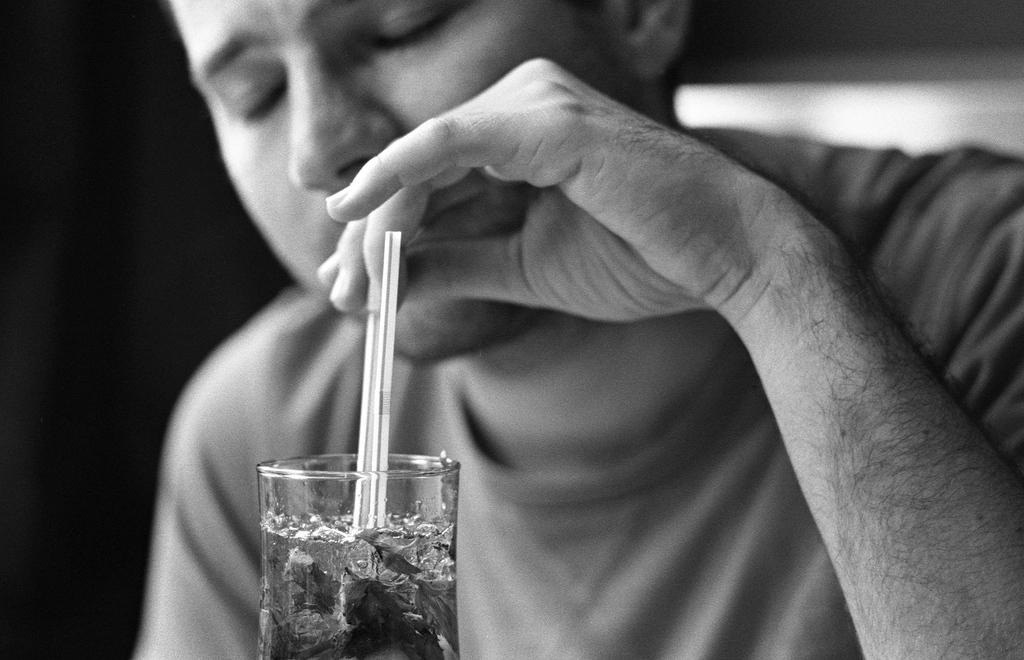What is present in the image? There is a person in the image. What is the person doing in the image? The person is holding something in their hands and placing the object in a glass. What time of day is it in the image? The time of day is not mentioned or visible in the image, so it cannot be determined. 